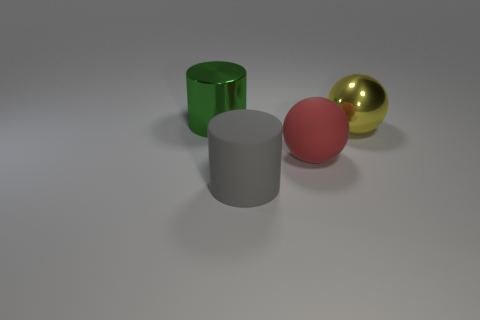There is a large metallic thing that is to the right of the green cylinder; is it the same shape as the large gray object?
Make the answer very short. No. How many objects are red rubber spheres or things that are in front of the yellow sphere?
Keep it short and to the point. 2. Are the sphere that is in front of the yellow metal ball and the gray cylinder made of the same material?
Offer a very short reply. Yes. What material is the large cylinder that is in front of the large metal object that is left of the yellow metallic sphere?
Make the answer very short. Rubber. Are there more metallic things in front of the green thing than green things right of the gray cylinder?
Keep it short and to the point. Yes. Are there any big yellow things behind the cylinder that is to the right of the green cylinder?
Keep it short and to the point. Yes. Are there fewer large gray matte cylinders that are in front of the large yellow object than big matte things that are right of the green thing?
Provide a short and direct response. Yes. There is a shiny object that is to the right of the metallic thing to the left of the large shiny thing that is to the right of the big gray rubber thing; what size is it?
Keep it short and to the point. Large. How many other objects are there of the same material as the red object?
Give a very brief answer. 1. Are there more big yellow balls than large green metal balls?
Provide a short and direct response. Yes. 